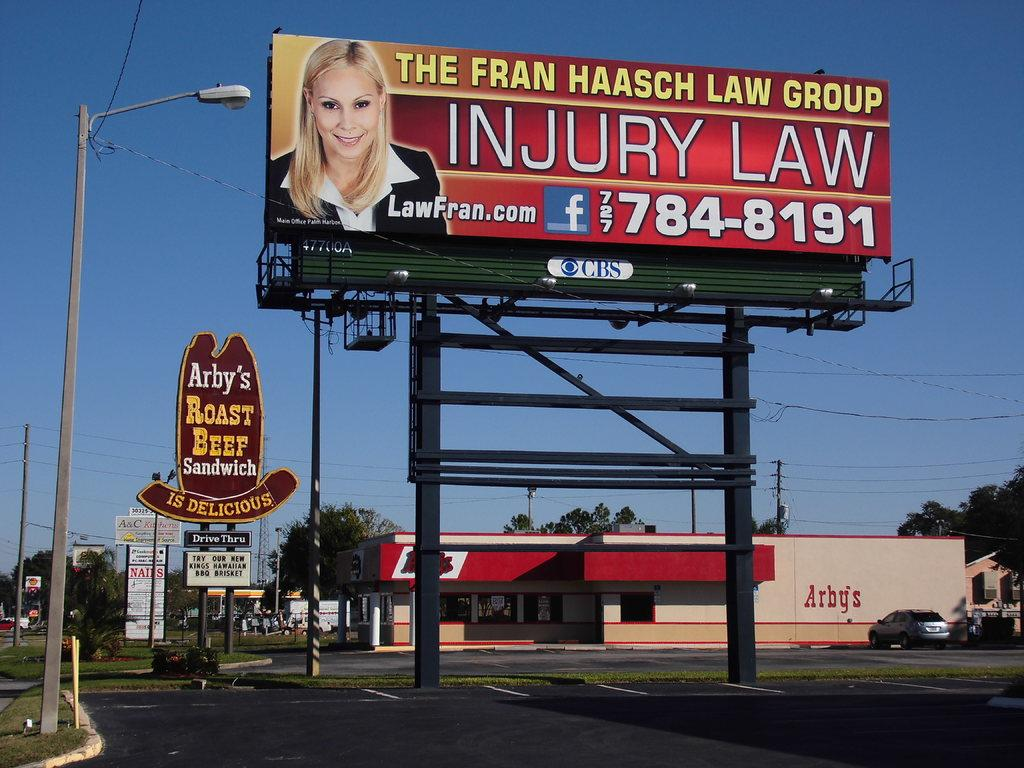<image>
Give a short and clear explanation of the subsequent image. roadside billboard for the fran haasch law firm 